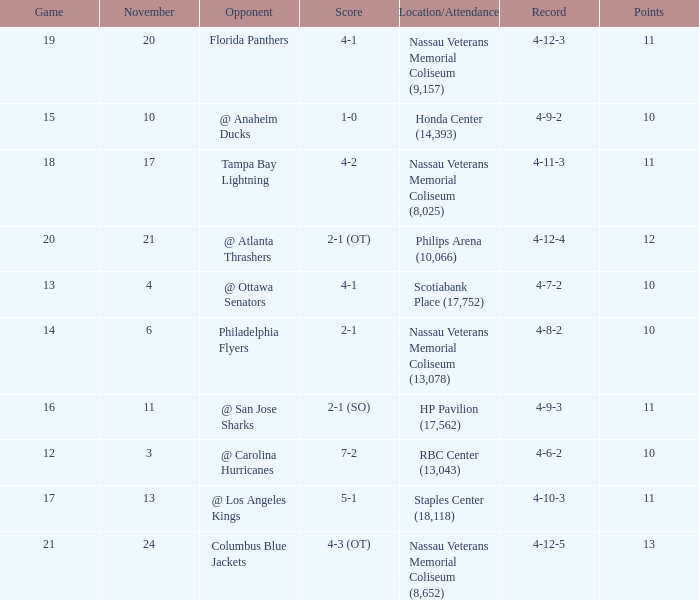What is every game on November 21? 20.0. 